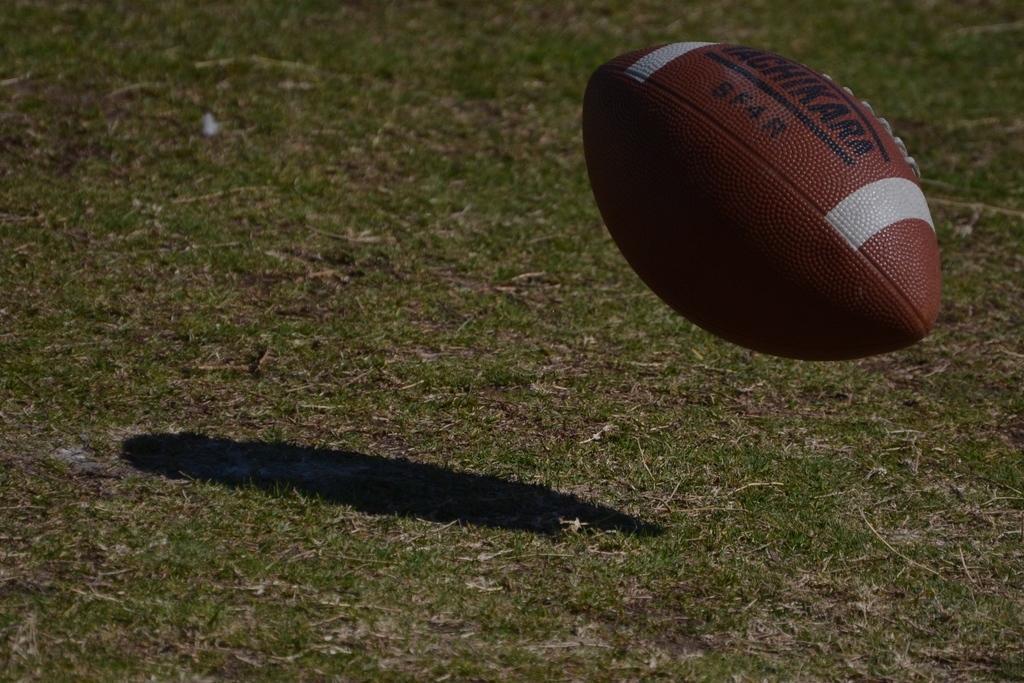How would you summarize this image in a sentence or two? In the image in the center, we can see one ball, which is in brown and white color. And we can see something written on the ball. In the background we can see the grass. 